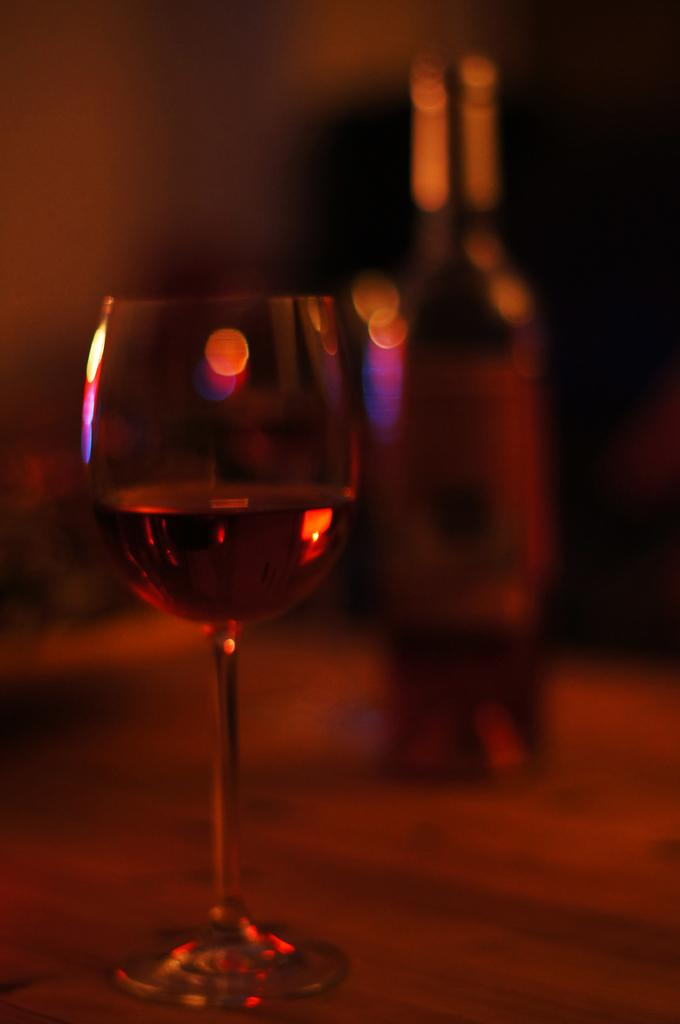What is on the left side of the image? There is a glass with a drink on the left side of the image. What is on the right side of the image? There is a bottle on the right side of the image. What color is the background of the image? The background of the image appears to be black. What type of argument is taking place in the image? There is no argument present in the image; it only features a glass with a drink and a bottle. How many bananas can be seen in the image? There are no bananas present in the image. 